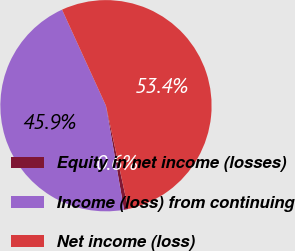Convert chart. <chart><loc_0><loc_0><loc_500><loc_500><pie_chart><fcel>Equity in net income (losses)<fcel>Income (loss) from continuing<fcel>Net income (loss)<nl><fcel>0.65%<fcel>45.91%<fcel>53.44%<nl></chart> 